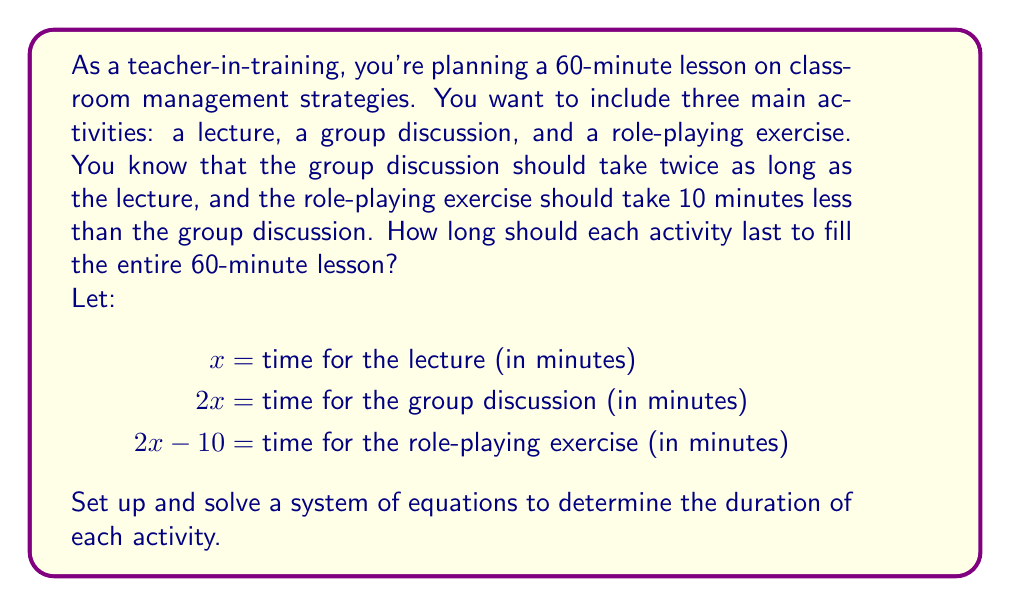Solve this math problem. To solve this problem, we'll follow these steps:

1. Set up an equation based on the total time:
   The sum of all activities should equal 60 minutes.
   $$x + 2x + (2x - 10) = 60$$

2. Simplify the equation:
   $$x + 2x + 2x - 10 = 60$$
   $$5x - 10 = 60$$

3. Solve for $x$:
   $$5x = 70$$
   $$x = 14$$

4. Calculate the time for each activity:
   - Lecture: $x = 14$ minutes
   - Group discussion: $2x = 2(14) = 28$ minutes
   - Role-playing exercise: $2x - 10 = 2(14) - 10 = 18$ minutes

5. Verify the solution:
   $$14 + 28 + 18 = 60$$

The solution satisfies the conditions and adds up to 60 minutes.
Answer: Lecture: 14 minutes
Group discussion: 28 minutes
Role-playing exercise: 18 minutes 